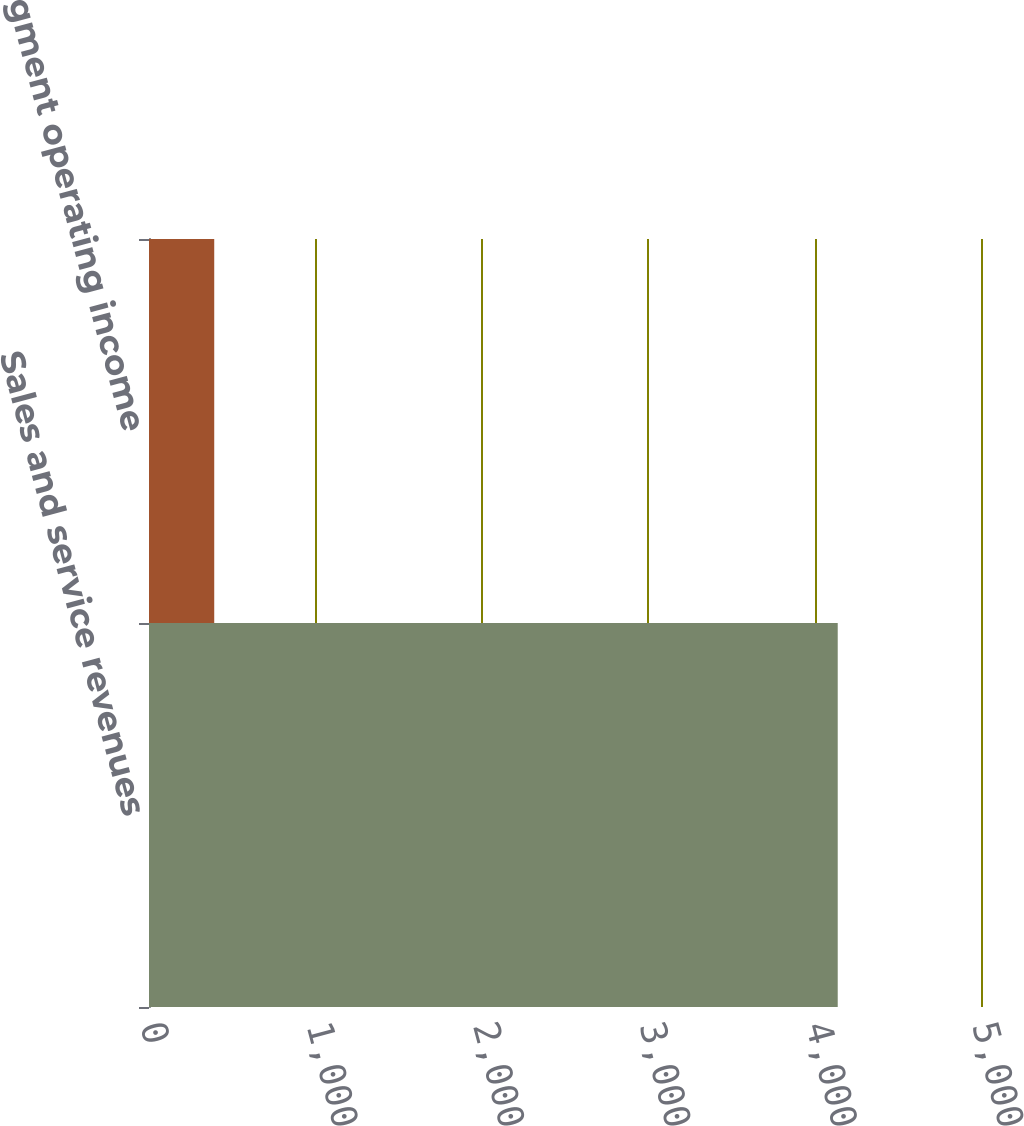<chart> <loc_0><loc_0><loc_500><loc_500><bar_chart><fcel>Sales and service revenues<fcel>Segment operating income<nl><fcel>4139<fcel>392<nl></chart> 